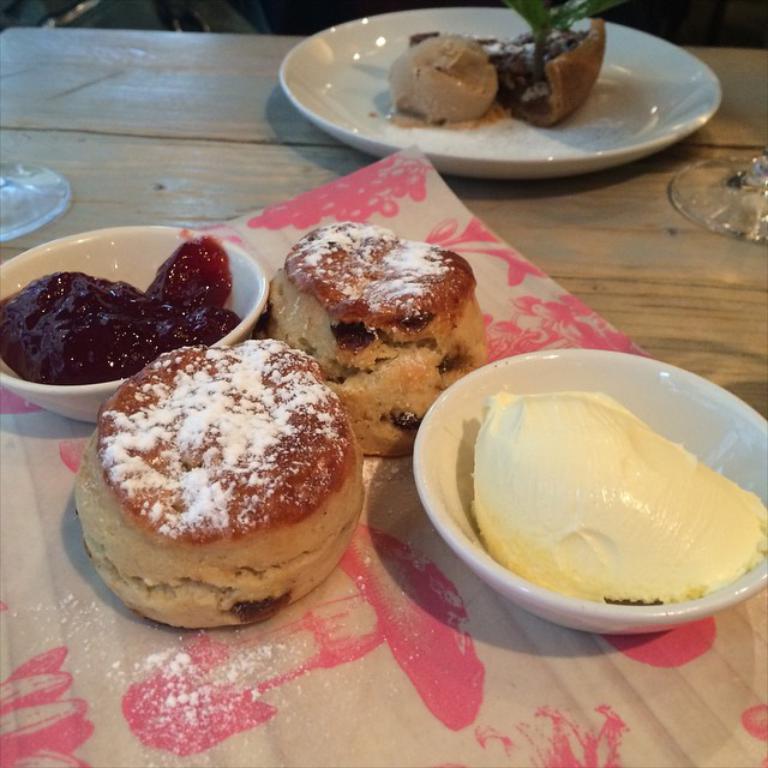Could you give a brief overview of what you see in this image? In this image, there is a table, on that table there is a cloth, there is some food and there are two white color bowls, in that bowls there is jam and butter, there is a white color plate, in that there is some food and there is a glass on the table. 